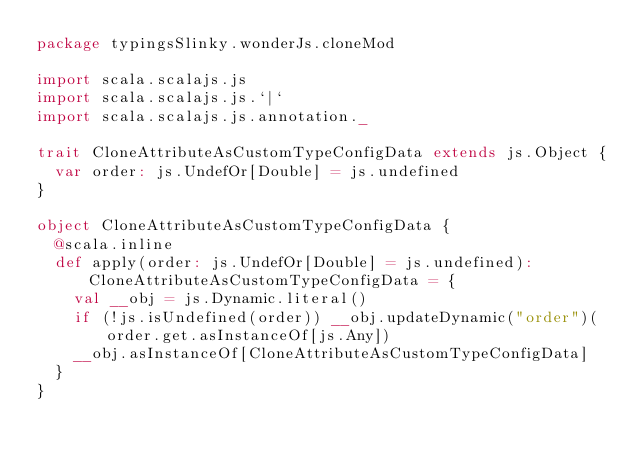Convert code to text. <code><loc_0><loc_0><loc_500><loc_500><_Scala_>package typingsSlinky.wonderJs.cloneMod

import scala.scalajs.js
import scala.scalajs.js.`|`
import scala.scalajs.js.annotation._

trait CloneAttributeAsCustomTypeConfigData extends js.Object {
  var order: js.UndefOr[Double] = js.undefined
}

object CloneAttributeAsCustomTypeConfigData {
  @scala.inline
  def apply(order: js.UndefOr[Double] = js.undefined): CloneAttributeAsCustomTypeConfigData = {
    val __obj = js.Dynamic.literal()
    if (!js.isUndefined(order)) __obj.updateDynamic("order")(order.get.asInstanceOf[js.Any])
    __obj.asInstanceOf[CloneAttributeAsCustomTypeConfigData]
  }
}

</code> 